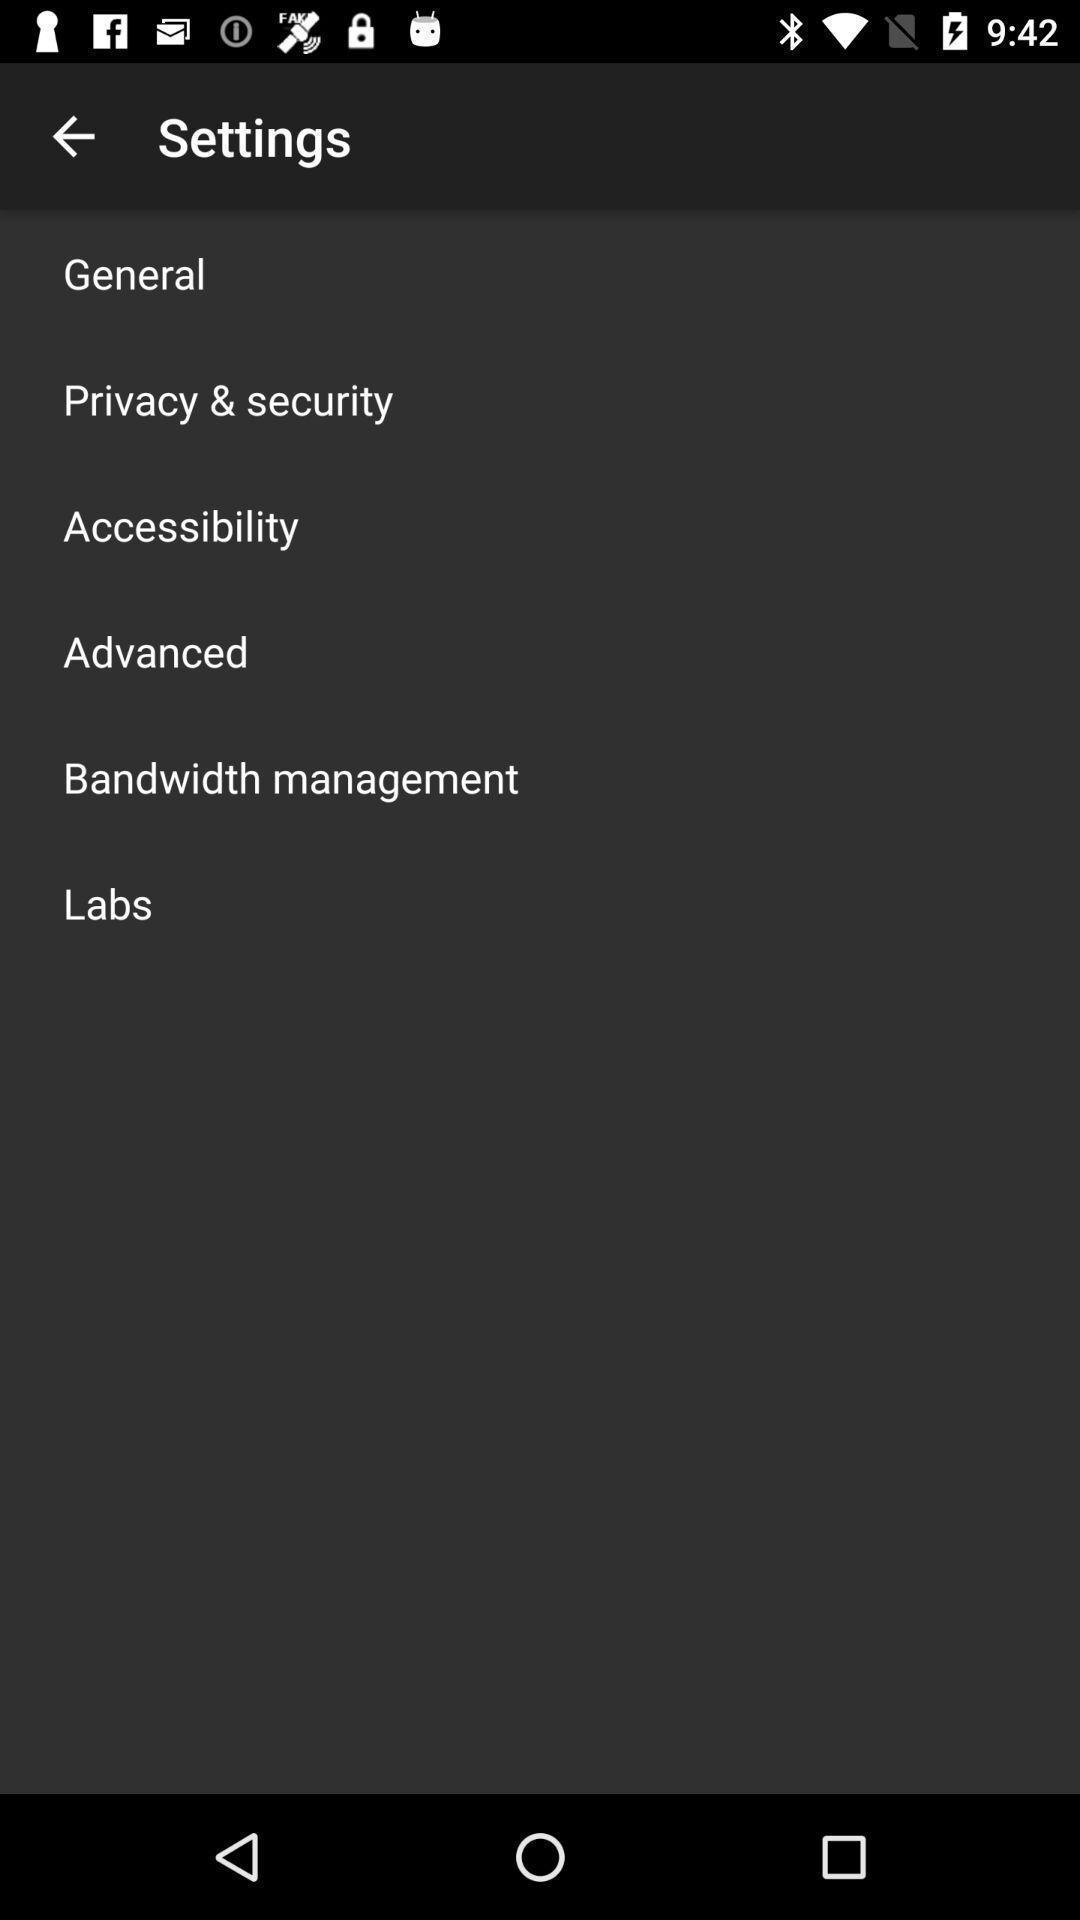Summarize the information in this screenshot. Screen showing settings page. 